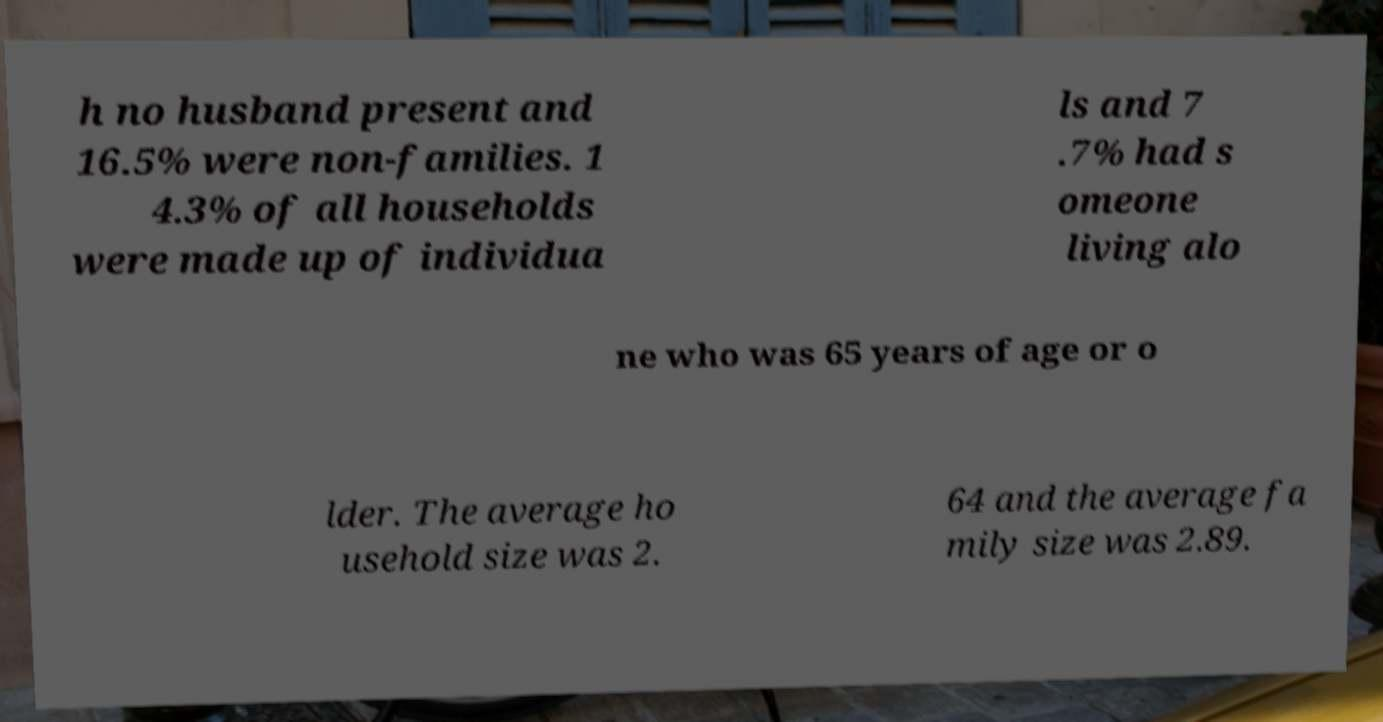What messages or text are displayed in this image? I need them in a readable, typed format. h no husband present and 16.5% were non-families. 1 4.3% of all households were made up of individua ls and 7 .7% had s omeone living alo ne who was 65 years of age or o lder. The average ho usehold size was 2. 64 and the average fa mily size was 2.89. 